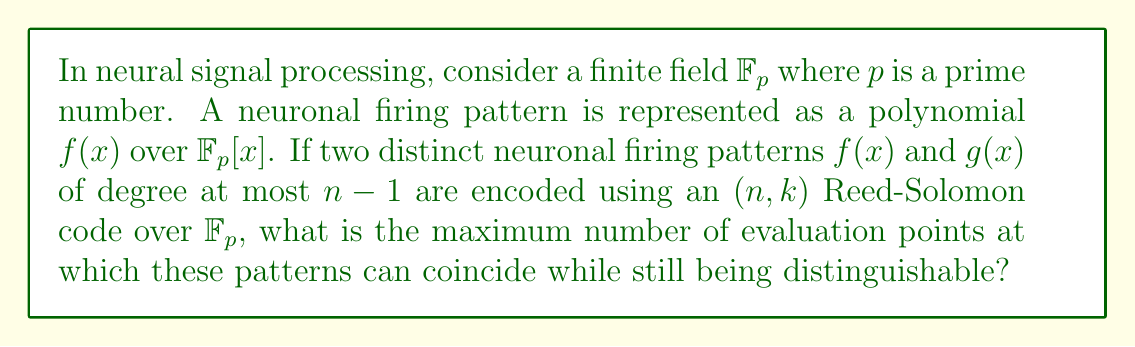What is the answer to this math problem? To solve this problem, we need to apply concepts from field theory and coding theory to neural signal processing. Let's break it down step-by-step:

1) In Reed-Solomon codes, polynomials of degree at most $k-1$ are used to encode messages. Here, we're told that the polynomials have degree at most $n-1$, so $k = n$ in this case.

2) The Reed-Solomon code is constructed by evaluating these polynomials at $n$ distinct points in the field $\mathbb{F}_p$.

3) Two distinct polynomials of degree at most $n-1$ can coincide at a maximum of $n-1$ points. This is because if they coincided at $n$ or more points, they would be the same polynomial (by the fundamental theorem of algebra over fields).

4) However, we need to ensure that the patterns are distinguishable. For Reed-Solomon codes, the minimum distance between codewords is $d = n - k + 1$.

5) In this case, since $k = n$, we have $d = 1$, which means the codewords must differ in at least one position to be distinguishable.

6) Therefore, the maximum number of evaluation points at which these patterns can coincide while still being distinguishable is $n-1$.

This result has important implications for neural signal processing. It suggests that even if two distinct neuronal firing patterns are very similar (coinciding at $n-1$ points), they can still be distinguished, allowing for precise differentiation of neural signals.
Answer: $n-1$ 